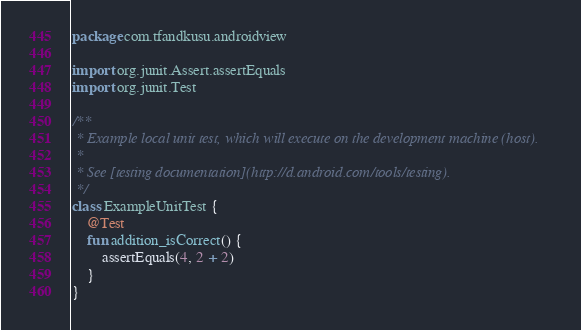Convert code to text. <code><loc_0><loc_0><loc_500><loc_500><_Kotlin_>package com.tfandkusu.androidview

import org.junit.Assert.assertEquals
import org.junit.Test

/**
 * Example local unit test, which will execute on the development machine (host).
 *
 * See [testing documentation](http://d.android.com/tools/testing).
 */
class ExampleUnitTest {
    @Test
    fun addition_isCorrect() {
        assertEquals(4, 2 + 2)
    }
}
</code> 